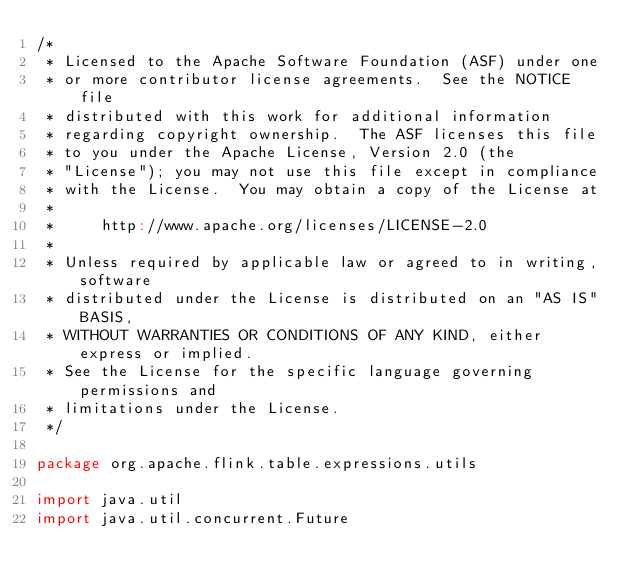<code> <loc_0><loc_0><loc_500><loc_500><_Scala_>/*
 * Licensed to the Apache Software Foundation (ASF) under one
 * or more contributor license agreements.  See the NOTICE file
 * distributed with this work for additional information
 * regarding copyright ownership.  The ASF licenses this file
 * to you under the Apache License, Version 2.0 (the
 * "License"); you may not use this file except in compliance
 * with the License.  You may obtain a copy of the License at
 *
 *     http://www.apache.org/licenses/LICENSE-2.0
 *
 * Unless required by applicable law or agreed to in writing, software
 * distributed under the License is distributed on an "AS IS" BASIS,
 * WITHOUT WARRANTIES OR CONDITIONS OF ANY KIND, either express or implied.
 * See the License for the specific language governing permissions and
 * limitations under the License.
 */

package org.apache.flink.table.expressions.utils

import java.util
import java.util.concurrent.Future</code> 